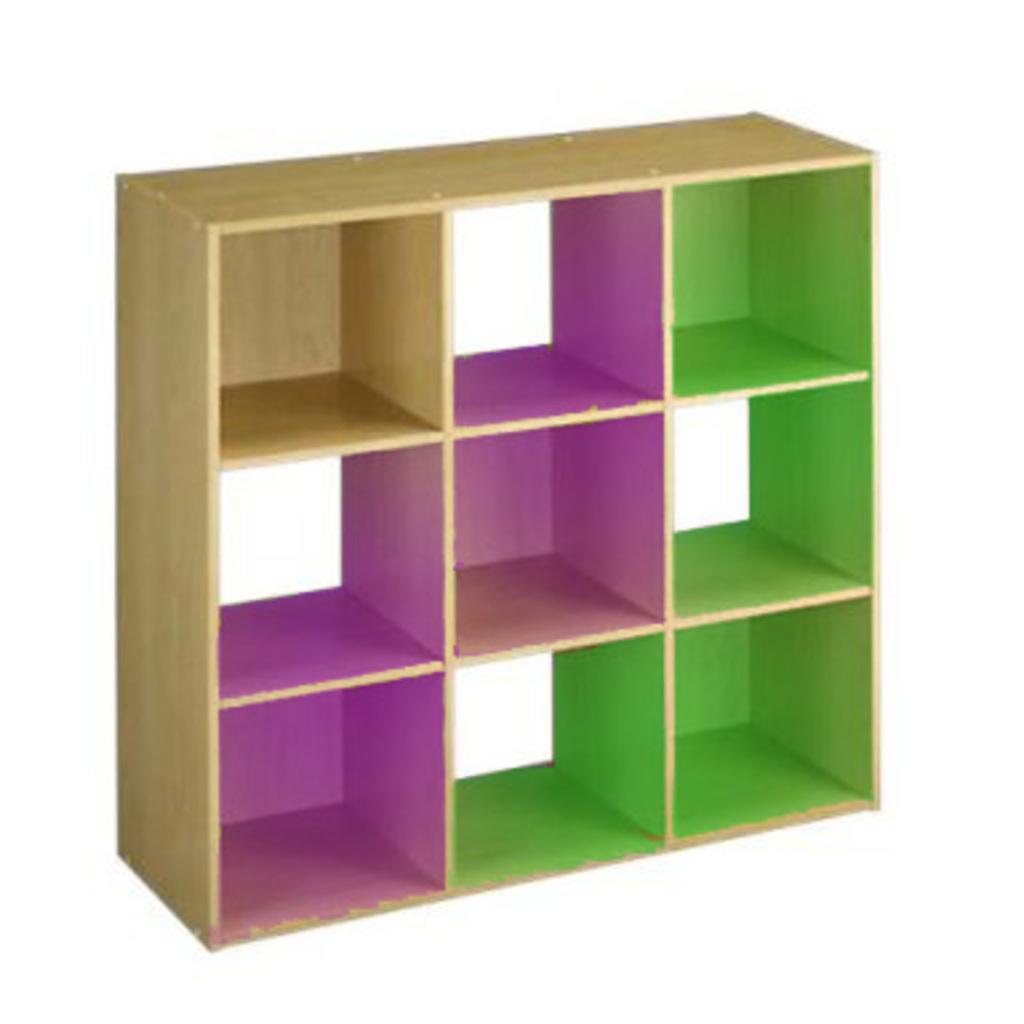Please provide a concise description of this image. In the picture we can see a wooden rack with some colors to it like pink and green. 